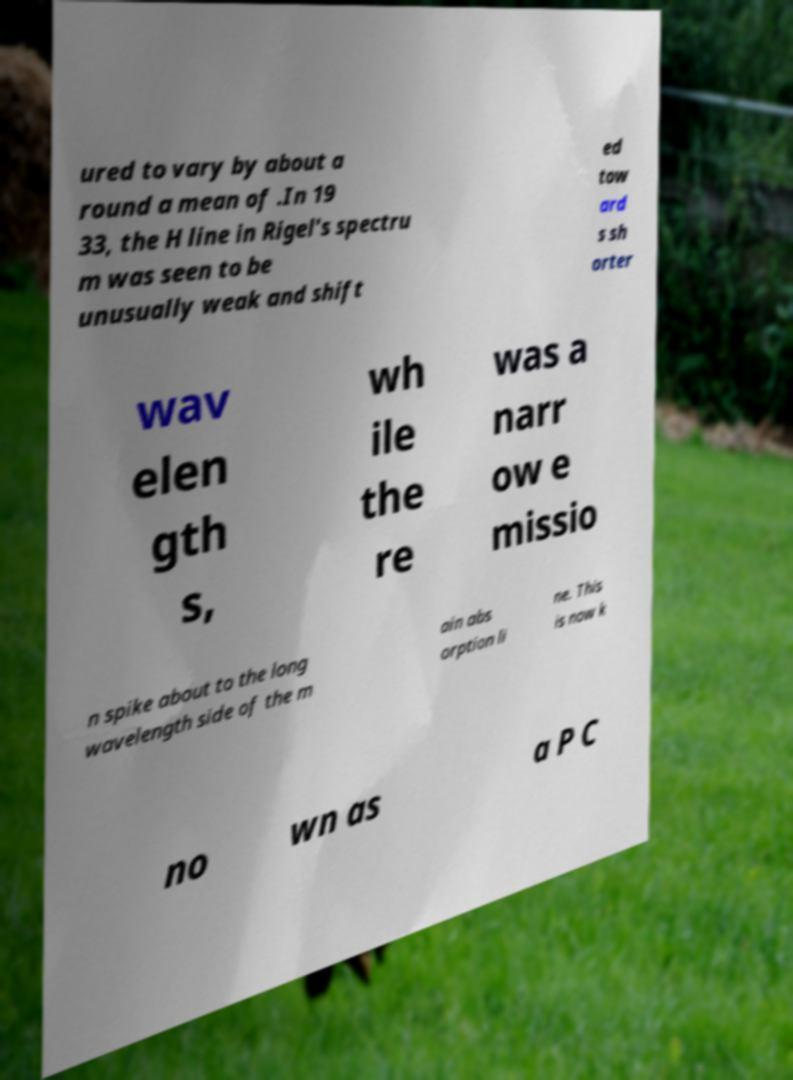Could you assist in decoding the text presented in this image and type it out clearly? ured to vary by about a round a mean of .In 19 33, the H line in Rigel's spectru m was seen to be unusually weak and shift ed tow ard s sh orter wav elen gth s, wh ile the re was a narr ow e missio n spike about to the long wavelength side of the m ain abs orption li ne. This is now k no wn as a P C 